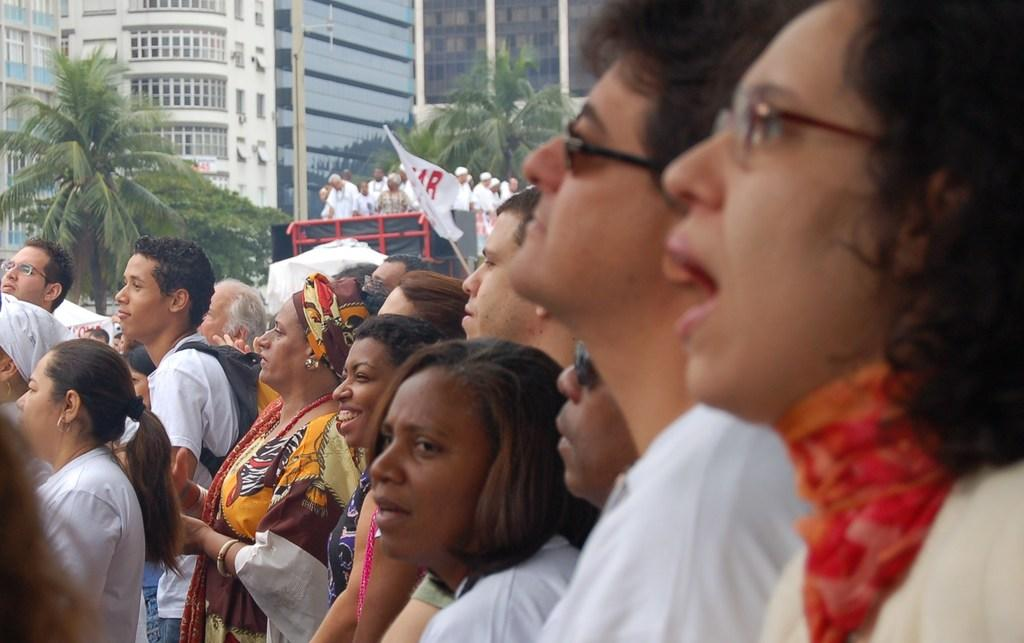What is the main subject of the image? The main subject of the image is a crowd. What can be seen in the center of the image? There is a flag in the center of the image. What is visible in the background of the image? There are trees and buildings in the background of the image. What type of nerve can be seen in the image? There is no nerve present in the image. What instrument is being played by the crowd in the image? There is no instrument being played by the crowd in the image. 